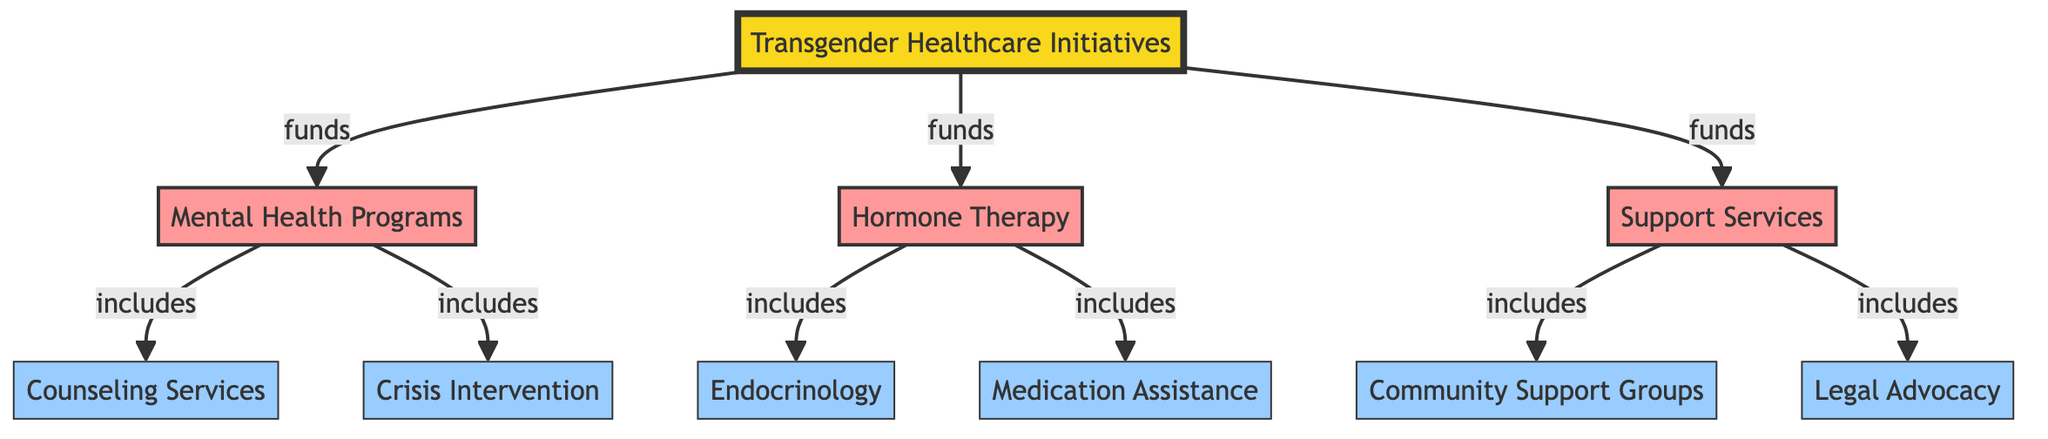What are the main categories of spending in this diagram? The diagram shows three main categories of spending: Mental Health Programs, Hormone Therapy, and Support Services. These categories emerge directly from the main node "Transgender Healthcare Initiatives."
Answer: Mental Health Programs, Hormone Therapy, Support Services How many subcategories are listed under Support Services? The Support Services category includes two subcategories: Community Support Groups and Legal Advocacy. These two nodes branch off from the Support Services node, indicating they are part of this category.
Answer: 2 What relationship exists between Mental Health Programs and Counseling Services? Counseling Services is a subcategory of Mental Health Programs, as illustrated by the directed edge from Mental Health Programs to Counseling Services in the diagram. This signifies that counseling services are included in mental health programs.
Answer: includes Which category includes Endocrinology? Endocrinology is a subcategory of Hormone Therapy, as shown by the directed edge connecting Hormone Therapy to Endocrinology in the diagram. This establishes that endocrinology falls under the expenditures for hormone therapy services.
Answer: Hormone Therapy How many total nodes are there in the diagram? The diagram consists of a total of 10 nodes, including the main node, three categories, and six subcategories. To determine this, one can count the main node (1), the three categories (3), and the six subcategories (6), resulting in 1 + 3 + 6 = 10.
Answer: 10 What is the hierarchy level of Crisis Intervention in the diagram? Crisis Intervention is one level below the Mental Health Programs category and is classified as a subcategory within that. The hierarchy flows from the main category down to the specific subcategory, indicating that Crisis Intervention is a part of Mental Health Programs.
Answer: 2 